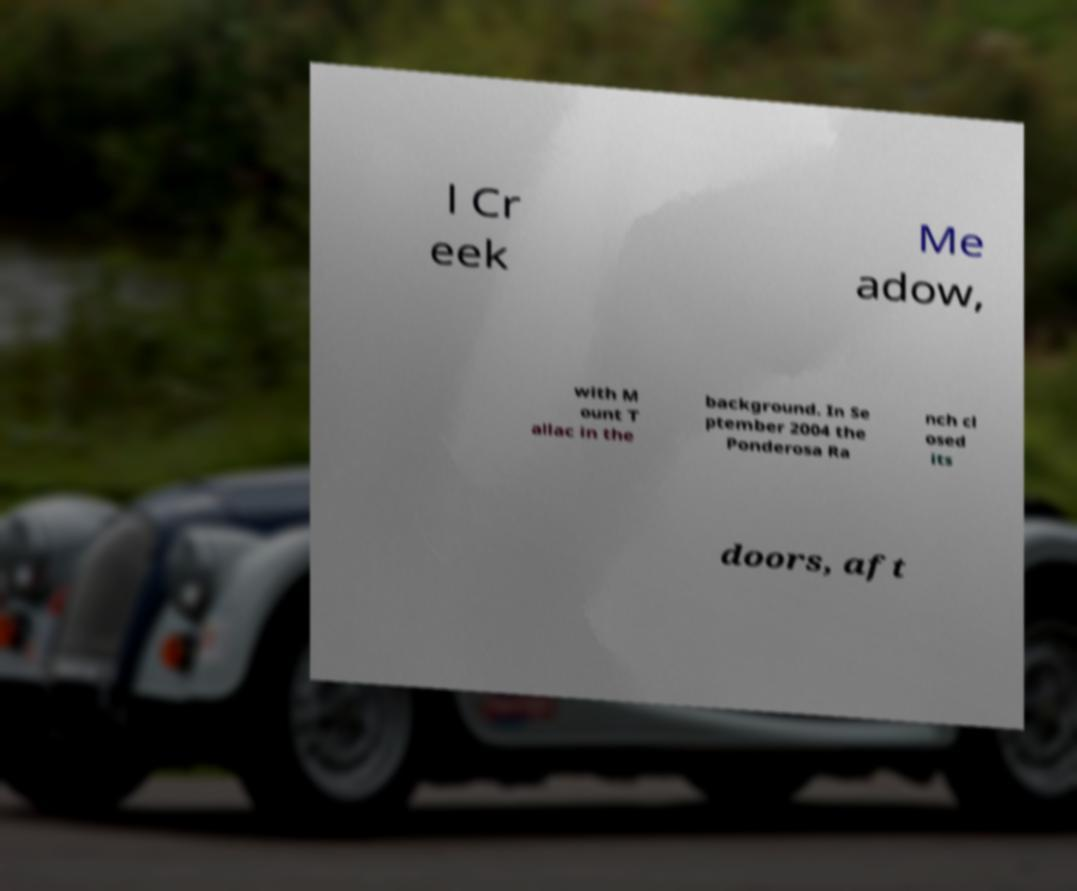Can you accurately transcribe the text from the provided image for me? l Cr eek Me adow, with M ount T allac in the background. In Se ptember 2004 the Ponderosa Ra nch cl osed its doors, aft 